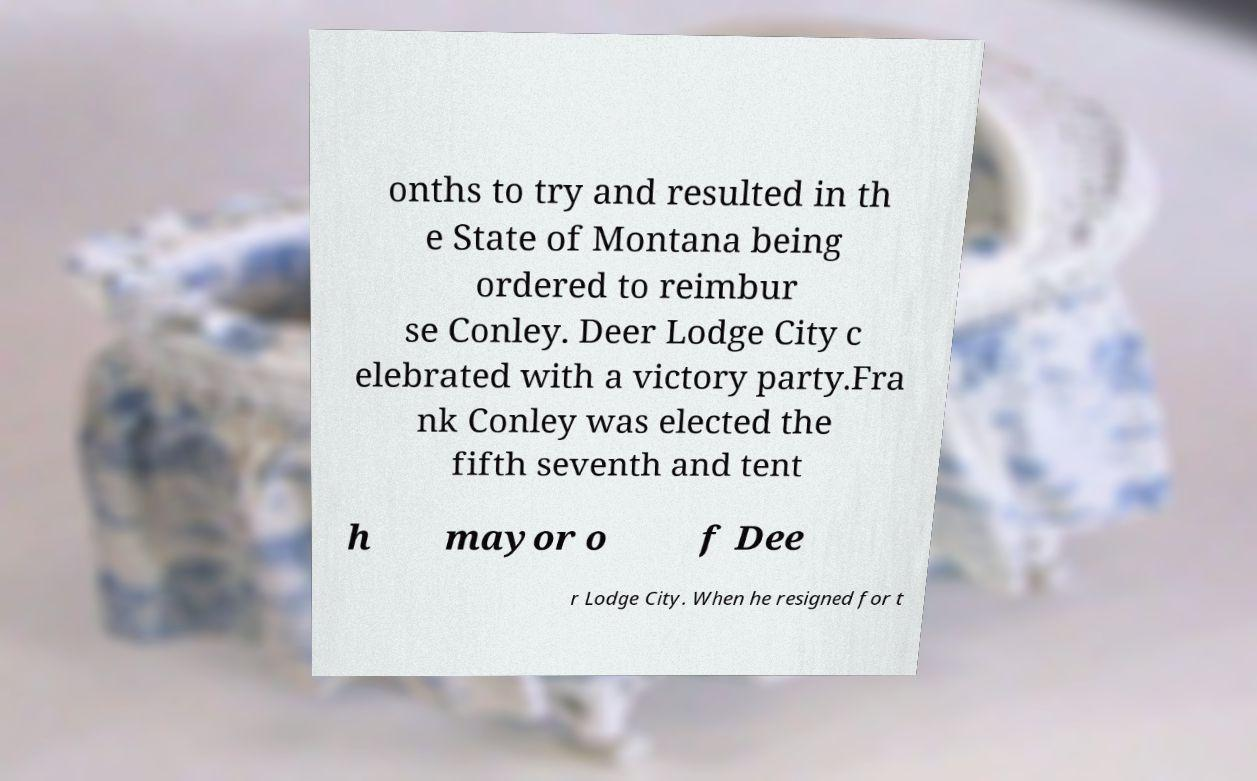I need the written content from this picture converted into text. Can you do that? onths to try and resulted in th e State of Montana being ordered to reimbur se Conley. Deer Lodge City c elebrated with a victory party.Fra nk Conley was elected the fifth seventh and tent h mayor o f Dee r Lodge City. When he resigned for t 